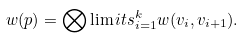<formula> <loc_0><loc_0><loc_500><loc_500>w ( p ) = \bigotimes \lim i t s _ { i = 1 } ^ { k } w ( v _ { i } , v _ { i + 1 } ) .</formula> 